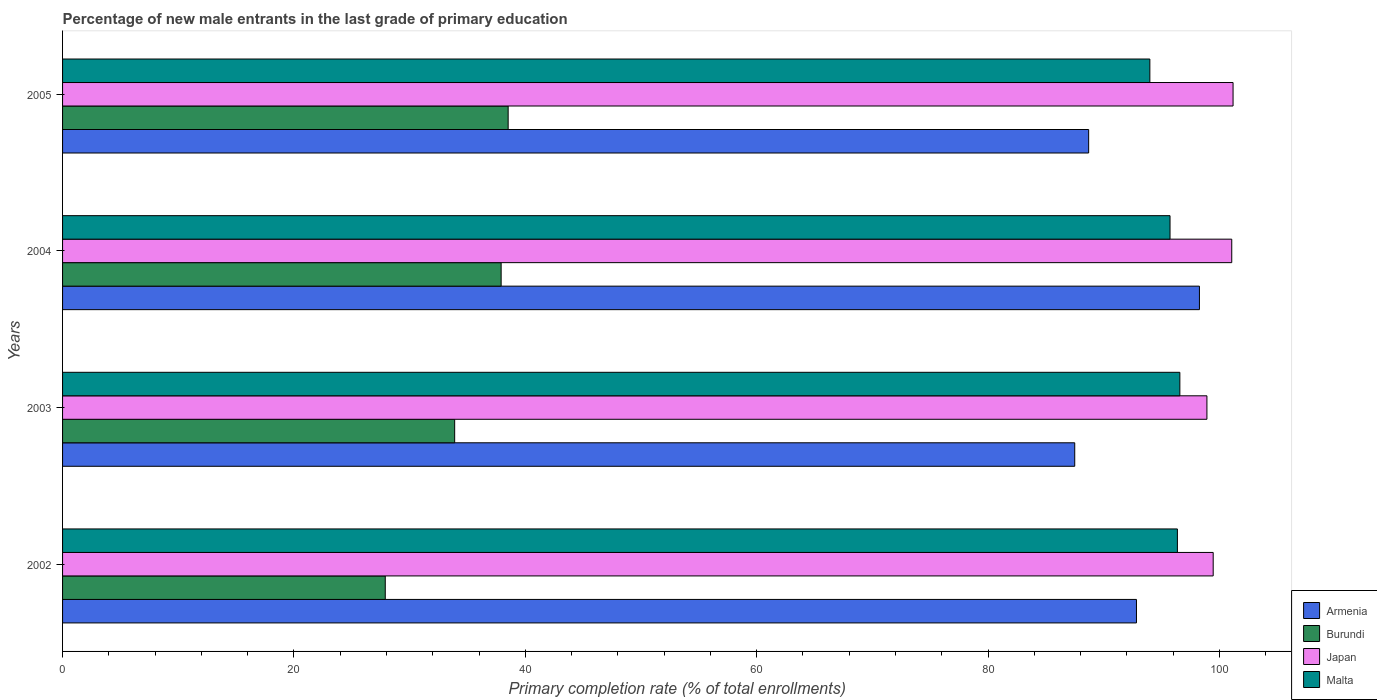How many different coloured bars are there?
Keep it short and to the point. 4. How many bars are there on the 1st tick from the top?
Keep it short and to the point. 4. What is the label of the 3rd group of bars from the top?
Ensure brevity in your answer.  2003. In how many cases, is the number of bars for a given year not equal to the number of legend labels?
Make the answer very short. 0. What is the percentage of new male entrants in Armenia in 2004?
Give a very brief answer. 98.27. Across all years, what is the maximum percentage of new male entrants in Armenia?
Offer a terse response. 98.27. Across all years, what is the minimum percentage of new male entrants in Malta?
Your answer should be compact. 93.99. In which year was the percentage of new male entrants in Burundi minimum?
Your response must be concise. 2002. What is the total percentage of new male entrants in Japan in the graph?
Your answer should be very brief. 400.63. What is the difference between the percentage of new male entrants in Japan in 2002 and that in 2003?
Ensure brevity in your answer.  0.54. What is the difference between the percentage of new male entrants in Armenia in 2005 and the percentage of new male entrants in Burundi in 2003?
Ensure brevity in your answer.  54.8. What is the average percentage of new male entrants in Japan per year?
Your answer should be compact. 100.16. In the year 2005, what is the difference between the percentage of new male entrants in Armenia and percentage of new male entrants in Burundi?
Provide a short and direct response. 50.18. In how many years, is the percentage of new male entrants in Burundi greater than 40 %?
Your answer should be compact. 0. What is the ratio of the percentage of new male entrants in Malta in 2003 to that in 2005?
Make the answer very short. 1.03. Is the percentage of new male entrants in Malta in 2003 less than that in 2004?
Offer a terse response. No. Is the difference between the percentage of new male entrants in Armenia in 2004 and 2005 greater than the difference between the percentage of new male entrants in Burundi in 2004 and 2005?
Provide a short and direct response. Yes. What is the difference between the highest and the second highest percentage of new male entrants in Armenia?
Give a very brief answer. 5.44. What is the difference between the highest and the lowest percentage of new male entrants in Burundi?
Your response must be concise. 10.62. In how many years, is the percentage of new male entrants in Armenia greater than the average percentage of new male entrants in Armenia taken over all years?
Provide a short and direct response. 2. Is the sum of the percentage of new male entrants in Malta in 2002 and 2004 greater than the maximum percentage of new male entrants in Japan across all years?
Offer a very short reply. Yes. Is it the case that in every year, the sum of the percentage of new male entrants in Burundi and percentage of new male entrants in Armenia is greater than the sum of percentage of new male entrants in Malta and percentage of new male entrants in Japan?
Offer a very short reply. Yes. What does the 1st bar from the top in 2005 represents?
Provide a succinct answer. Malta. Does the graph contain any zero values?
Offer a very short reply. No. Does the graph contain grids?
Provide a succinct answer. No. What is the title of the graph?
Give a very brief answer. Percentage of new male entrants in the last grade of primary education. What is the label or title of the X-axis?
Keep it short and to the point. Primary completion rate (% of total enrollments). What is the label or title of the Y-axis?
Make the answer very short. Years. What is the Primary completion rate (% of total enrollments) of Armenia in 2002?
Give a very brief answer. 92.83. What is the Primary completion rate (% of total enrollments) of Burundi in 2002?
Give a very brief answer. 27.89. What is the Primary completion rate (% of total enrollments) in Japan in 2002?
Your answer should be compact. 99.46. What is the Primary completion rate (% of total enrollments) in Malta in 2002?
Provide a succinct answer. 96.37. What is the Primary completion rate (% of total enrollments) in Armenia in 2003?
Offer a terse response. 87.49. What is the Primary completion rate (% of total enrollments) in Burundi in 2003?
Provide a short and direct response. 33.89. What is the Primary completion rate (% of total enrollments) in Japan in 2003?
Provide a succinct answer. 98.92. What is the Primary completion rate (% of total enrollments) of Malta in 2003?
Offer a terse response. 96.58. What is the Primary completion rate (% of total enrollments) of Armenia in 2004?
Your answer should be very brief. 98.27. What is the Primary completion rate (% of total enrollments) of Burundi in 2004?
Your answer should be compact. 37.91. What is the Primary completion rate (% of total enrollments) of Japan in 2004?
Provide a short and direct response. 101.07. What is the Primary completion rate (% of total enrollments) in Malta in 2004?
Give a very brief answer. 95.73. What is the Primary completion rate (% of total enrollments) of Armenia in 2005?
Give a very brief answer. 88.7. What is the Primary completion rate (% of total enrollments) of Burundi in 2005?
Your response must be concise. 38.52. What is the Primary completion rate (% of total enrollments) of Japan in 2005?
Offer a very short reply. 101.18. What is the Primary completion rate (% of total enrollments) of Malta in 2005?
Your answer should be very brief. 93.99. Across all years, what is the maximum Primary completion rate (% of total enrollments) of Armenia?
Provide a succinct answer. 98.27. Across all years, what is the maximum Primary completion rate (% of total enrollments) in Burundi?
Your answer should be very brief. 38.52. Across all years, what is the maximum Primary completion rate (% of total enrollments) of Japan?
Provide a short and direct response. 101.18. Across all years, what is the maximum Primary completion rate (% of total enrollments) of Malta?
Ensure brevity in your answer.  96.58. Across all years, what is the minimum Primary completion rate (% of total enrollments) in Armenia?
Give a very brief answer. 87.49. Across all years, what is the minimum Primary completion rate (% of total enrollments) of Burundi?
Your answer should be very brief. 27.89. Across all years, what is the minimum Primary completion rate (% of total enrollments) in Japan?
Make the answer very short. 98.92. Across all years, what is the minimum Primary completion rate (% of total enrollments) in Malta?
Provide a short and direct response. 93.99. What is the total Primary completion rate (% of total enrollments) in Armenia in the graph?
Give a very brief answer. 367.29. What is the total Primary completion rate (% of total enrollments) in Burundi in the graph?
Offer a terse response. 138.22. What is the total Primary completion rate (% of total enrollments) in Japan in the graph?
Offer a very short reply. 400.63. What is the total Primary completion rate (% of total enrollments) of Malta in the graph?
Offer a very short reply. 382.67. What is the difference between the Primary completion rate (% of total enrollments) in Armenia in 2002 and that in 2003?
Give a very brief answer. 5.34. What is the difference between the Primary completion rate (% of total enrollments) in Burundi in 2002 and that in 2003?
Keep it short and to the point. -6. What is the difference between the Primary completion rate (% of total enrollments) in Japan in 2002 and that in 2003?
Ensure brevity in your answer.  0.54. What is the difference between the Primary completion rate (% of total enrollments) of Malta in 2002 and that in 2003?
Keep it short and to the point. -0.21. What is the difference between the Primary completion rate (% of total enrollments) in Armenia in 2002 and that in 2004?
Provide a succinct answer. -5.44. What is the difference between the Primary completion rate (% of total enrollments) in Burundi in 2002 and that in 2004?
Give a very brief answer. -10.02. What is the difference between the Primary completion rate (% of total enrollments) of Japan in 2002 and that in 2004?
Offer a very short reply. -1.6. What is the difference between the Primary completion rate (% of total enrollments) in Malta in 2002 and that in 2004?
Offer a very short reply. 0.64. What is the difference between the Primary completion rate (% of total enrollments) in Armenia in 2002 and that in 2005?
Your answer should be compact. 4.13. What is the difference between the Primary completion rate (% of total enrollments) in Burundi in 2002 and that in 2005?
Ensure brevity in your answer.  -10.62. What is the difference between the Primary completion rate (% of total enrollments) in Japan in 2002 and that in 2005?
Your answer should be compact. -1.72. What is the difference between the Primary completion rate (% of total enrollments) in Malta in 2002 and that in 2005?
Your answer should be very brief. 2.38. What is the difference between the Primary completion rate (% of total enrollments) in Armenia in 2003 and that in 2004?
Offer a terse response. -10.78. What is the difference between the Primary completion rate (% of total enrollments) of Burundi in 2003 and that in 2004?
Provide a succinct answer. -4.02. What is the difference between the Primary completion rate (% of total enrollments) of Japan in 2003 and that in 2004?
Your response must be concise. -2.15. What is the difference between the Primary completion rate (% of total enrollments) of Armenia in 2003 and that in 2005?
Make the answer very short. -1.2. What is the difference between the Primary completion rate (% of total enrollments) of Burundi in 2003 and that in 2005?
Keep it short and to the point. -4.62. What is the difference between the Primary completion rate (% of total enrollments) in Japan in 2003 and that in 2005?
Ensure brevity in your answer.  -2.26. What is the difference between the Primary completion rate (% of total enrollments) in Malta in 2003 and that in 2005?
Provide a succinct answer. 2.59. What is the difference between the Primary completion rate (% of total enrollments) of Armenia in 2004 and that in 2005?
Give a very brief answer. 9.58. What is the difference between the Primary completion rate (% of total enrollments) of Burundi in 2004 and that in 2005?
Your response must be concise. -0.61. What is the difference between the Primary completion rate (% of total enrollments) in Japan in 2004 and that in 2005?
Ensure brevity in your answer.  -0.11. What is the difference between the Primary completion rate (% of total enrollments) of Malta in 2004 and that in 2005?
Offer a terse response. 1.74. What is the difference between the Primary completion rate (% of total enrollments) of Armenia in 2002 and the Primary completion rate (% of total enrollments) of Burundi in 2003?
Your response must be concise. 58.94. What is the difference between the Primary completion rate (% of total enrollments) in Armenia in 2002 and the Primary completion rate (% of total enrollments) in Japan in 2003?
Make the answer very short. -6.09. What is the difference between the Primary completion rate (% of total enrollments) of Armenia in 2002 and the Primary completion rate (% of total enrollments) of Malta in 2003?
Your answer should be compact. -3.75. What is the difference between the Primary completion rate (% of total enrollments) of Burundi in 2002 and the Primary completion rate (% of total enrollments) of Japan in 2003?
Your response must be concise. -71.03. What is the difference between the Primary completion rate (% of total enrollments) of Burundi in 2002 and the Primary completion rate (% of total enrollments) of Malta in 2003?
Your answer should be compact. -68.69. What is the difference between the Primary completion rate (% of total enrollments) of Japan in 2002 and the Primary completion rate (% of total enrollments) of Malta in 2003?
Your response must be concise. 2.88. What is the difference between the Primary completion rate (% of total enrollments) in Armenia in 2002 and the Primary completion rate (% of total enrollments) in Burundi in 2004?
Offer a terse response. 54.92. What is the difference between the Primary completion rate (% of total enrollments) of Armenia in 2002 and the Primary completion rate (% of total enrollments) of Japan in 2004?
Your answer should be compact. -8.24. What is the difference between the Primary completion rate (% of total enrollments) in Armenia in 2002 and the Primary completion rate (% of total enrollments) in Malta in 2004?
Your answer should be compact. -2.9. What is the difference between the Primary completion rate (% of total enrollments) of Burundi in 2002 and the Primary completion rate (% of total enrollments) of Japan in 2004?
Ensure brevity in your answer.  -73.17. What is the difference between the Primary completion rate (% of total enrollments) in Burundi in 2002 and the Primary completion rate (% of total enrollments) in Malta in 2004?
Give a very brief answer. -67.84. What is the difference between the Primary completion rate (% of total enrollments) in Japan in 2002 and the Primary completion rate (% of total enrollments) in Malta in 2004?
Your response must be concise. 3.73. What is the difference between the Primary completion rate (% of total enrollments) of Armenia in 2002 and the Primary completion rate (% of total enrollments) of Burundi in 2005?
Keep it short and to the point. 54.31. What is the difference between the Primary completion rate (% of total enrollments) of Armenia in 2002 and the Primary completion rate (% of total enrollments) of Japan in 2005?
Provide a short and direct response. -8.35. What is the difference between the Primary completion rate (% of total enrollments) in Armenia in 2002 and the Primary completion rate (% of total enrollments) in Malta in 2005?
Your answer should be very brief. -1.16. What is the difference between the Primary completion rate (% of total enrollments) of Burundi in 2002 and the Primary completion rate (% of total enrollments) of Japan in 2005?
Offer a very short reply. -73.29. What is the difference between the Primary completion rate (% of total enrollments) of Burundi in 2002 and the Primary completion rate (% of total enrollments) of Malta in 2005?
Your answer should be very brief. -66.09. What is the difference between the Primary completion rate (% of total enrollments) of Japan in 2002 and the Primary completion rate (% of total enrollments) of Malta in 2005?
Ensure brevity in your answer.  5.47. What is the difference between the Primary completion rate (% of total enrollments) in Armenia in 2003 and the Primary completion rate (% of total enrollments) in Burundi in 2004?
Ensure brevity in your answer.  49.58. What is the difference between the Primary completion rate (% of total enrollments) of Armenia in 2003 and the Primary completion rate (% of total enrollments) of Japan in 2004?
Offer a very short reply. -13.57. What is the difference between the Primary completion rate (% of total enrollments) in Armenia in 2003 and the Primary completion rate (% of total enrollments) in Malta in 2004?
Offer a very short reply. -8.24. What is the difference between the Primary completion rate (% of total enrollments) of Burundi in 2003 and the Primary completion rate (% of total enrollments) of Japan in 2004?
Provide a short and direct response. -67.17. What is the difference between the Primary completion rate (% of total enrollments) of Burundi in 2003 and the Primary completion rate (% of total enrollments) of Malta in 2004?
Your answer should be compact. -61.84. What is the difference between the Primary completion rate (% of total enrollments) in Japan in 2003 and the Primary completion rate (% of total enrollments) in Malta in 2004?
Provide a short and direct response. 3.19. What is the difference between the Primary completion rate (% of total enrollments) in Armenia in 2003 and the Primary completion rate (% of total enrollments) in Burundi in 2005?
Offer a very short reply. 48.98. What is the difference between the Primary completion rate (% of total enrollments) of Armenia in 2003 and the Primary completion rate (% of total enrollments) of Japan in 2005?
Your response must be concise. -13.69. What is the difference between the Primary completion rate (% of total enrollments) in Armenia in 2003 and the Primary completion rate (% of total enrollments) in Malta in 2005?
Ensure brevity in your answer.  -6.49. What is the difference between the Primary completion rate (% of total enrollments) in Burundi in 2003 and the Primary completion rate (% of total enrollments) in Japan in 2005?
Give a very brief answer. -67.29. What is the difference between the Primary completion rate (% of total enrollments) in Burundi in 2003 and the Primary completion rate (% of total enrollments) in Malta in 2005?
Offer a very short reply. -60.09. What is the difference between the Primary completion rate (% of total enrollments) of Japan in 2003 and the Primary completion rate (% of total enrollments) of Malta in 2005?
Provide a succinct answer. 4.93. What is the difference between the Primary completion rate (% of total enrollments) in Armenia in 2004 and the Primary completion rate (% of total enrollments) in Burundi in 2005?
Offer a very short reply. 59.75. What is the difference between the Primary completion rate (% of total enrollments) of Armenia in 2004 and the Primary completion rate (% of total enrollments) of Japan in 2005?
Provide a succinct answer. -2.91. What is the difference between the Primary completion rate (% of total enrollments) in Armenia in 2004 and the Primary completion rate (% of total enrollments) in Malta in 2005?
Your answer should be very brief. 4.29. What is the difference between the Primary completion rate (% of total enrollments) in Burundi in 2004 and the Primary completion rate (% of total enrollments) in Japan in 2005?
Keep it short and to the point. -63.27. What is the difference between the Primary completion rate (% of total enrollments) of Burundi in 2004 and the Primary completion rate (% of total enrollments) of Malta in 2005?
Provide a succinct answer. -56.08. What is the difference between the Primary completion rate (% of total enrollments) in Japan in 2004 and the Primary completion rate (% of total enrollments) in Malta in 2005?
Your answer should be very brief. 7.08. What is the average Primary completion rate (% of total enrollments) in Armenia per year?
Your answer should be compact. 91.82. What is the average Primary completion rate (% of total enrollments) in Burundi per year?
Your answer should be compact. 34.55. What is the average Primary completion rate (% of total enrollments) in Japan per year?
Your response must be concise. 100.16. What is the average Primary completion rate (% of total enrollments) of Malta per year?
Provide a short and direct response. 95.67. In the year 2002, what is the difference between the Primary completion rate (% of total enrollments) in Armenia and Primary completion rate (% of total enrollments) in Burundi?
Your answer should be compact. 64.94. In the year 2002, what is the difference between the Primary completion rate (% of total enrollments) of Armenia and Primary completion rate (% of total enrollments) of Japan?
Provide a succinct answer. -6.63. In the year 2002, what is the difference between the Primary completion rate (% of total enrollments) of Armenia and Primary completion rate (% of total enrollments) of Malta?
Your answer should be very brief. -3.54. In the year 2002, what is the difference between the Primary completion rate (% of total enrollments) in Burundi and Primary completion rate (% of total enrollments) in Japan?
Your answer should be very brief. -71.57. In the year 2002, what is the difference between the Primary completion rate (% of total enrollments) in Burundi and Primary completion rate (% of total enrollments) in Malta?
Your answer should be compact. -68.47. In the year 2002, what is the difference between the Primary completion rate (% of total enrollments) of Japan and Primary completion rate (% of total enrollments) of Malta?
Ensure brevity in your answer.  3.09. In the year 2003, what is the difference between the Primary completion rate (% of total enrollments) in Armenia and Primary completion rate (% of total enrollments) in Burundi?
Offer a very short reply. 53.6. In the year 2003, what is the difference between the Primary completion rate (% of total enrollments) in Armenia and Primary completion rate (% of total enrollments) in Japan?
Keep it short and to the point. -11.43. In the year 2003, what is the difference between the Primary completion rate (% of total enrollments) in Armenia and Primary completion rate (% of total enrollments) in Malta?
Provide a short and direct response. -9.09. In the year 2003, what is the difference between the Primary completion rate (% of total enrollments) of Burundi and Primary completion rate (% of total enrollments) of Japan?
Give a very brief answer. -65.02. In the year 2003, what is the difference between the Primary completion rate (% of total enrollments) of Burundi and Primary completion rate (% of total enrollments) of Malta?
Ensure brevity in your answer.  -62.69. In the year 2003, what is the difference between the Primary completion rate (% of total enrollments) of Japan and Primary completion rate (% of total enrollments) of Malta?
Make the answer very short. 2.34. In the year 2004, what is the difference between the Primary completion rate (% of total enrollments) of Armenia and Primary completion rate (% of total enrollments) of Burundi?
Make the answer very short. 60.36. In the year 2004, what is the difference between the Primary completion rate (% of total enrollments) in Armenia and Primary completion rate (% of total enrollments) in Japan?
Offer a terse response. -2.79. In the year 2004, what is the difference between the Primary completion rate (% of total enrollments) in Armenia and Primary completion rate (% of total enrollments) in Malta?
Offer a terse response. 2.54. In the year 2004, what is the difference between the Primary completion rate (% of total enrollments) in Burundi and Primary completion rate (% of total enrollments) in Japan?
Offer a terse response. -63.16. In the year 2004, what is the difference between the Primary completion rate (% of total enrollments) in Burundi and Primary completion rate (% of total enrollments) in Malta?
Provide a succinct answer. -57.82. In the year 2004, what is the difference between the Primary completion rate (% of total enrollments) of Japan and Primary completion rate (% of total enrollments) of Malta?
Provide a short and direct response. 5.34. In the year 2005, what is the difference between the Primary completion rate (% of total enrollments) of Armenia and Primary completion rate (% of total enrollments) of Burundi?
Provide a succinct answer. 50.18. In the year 2005, what is the difference between the Primary completion rate (% of total enrollments) of Armenia and Primary completion rate (% of total enrollments) of Japan?
Make the answer very short. -12.48. In the year 2005, what is the difference between the Primary completion rate (% of total enrollments) in Armenia and Primary completion rate (% of total enrollments) in Malta?
Offer a terse response. -5.29. In the year 2005, what is the difference between the Primary completion rate (% of total enrollments) of Burundi and Primary completion rate (% of total enrollments) of Japan?
Your answer should be very brief. -62.66. In the year 2005, what is the difference between the Primary completion rate (% of total enrollments) of Burundi and Primary completion rate (% of total enrollments) of Malta?
Keep it short and to the point. -55.47. In the year 2005, what is the difference between the Primary completion rate (% of total enrollments) of Japan and Primary completion rate (% of total enrollments) of Malta?
Offer a terse response. 7.19. What is the ratio of the Primary completion rate (% of total enrollments) of Armenia in 2002 to that in 2003?
Your answer should be very brief. 1.06. What is the ratio of the Primary completion rate (% of total enrollments) in Burundi in 2002 to that in 2003?
Your answer should be very brief. 0.82. What is the ratio of the Primary completion rate (% of total enrollments) of Japan in 2002 to that in 2003?
Make the answer very short. 1.01. What is the ratio of the Primary completion rate (% of total enrollments) in Malta in 2002 to that in 2003?
Your answer should be very brief. 1. What is the ratio of the Primary completion rate (% of total enrollments) of Armenia in 2002 to that in 2004?
Ensure brevity in your answer.  0.94. What is the ratio of the Primary completion rate (% of total enrollments) in Burundi in 2002 to that in 2004?
Provide a succinct answer. 0.74. What is the ratio of the Primary completion rate (% of total enrollments) of Japan in 2002 to that in 2004?
Ensure brevity in your answer.  0.98. What is the ratio of the Primary completion rate (% of total enrollments) in Malta in 2002 to that in 2004?
Your answer should be very brief. 1.01. What is the ratio of the Primary completion rate (% of total enrollments) of Armenia in 2002 to that in 2005?
Provide a succinct answer. 1.05. What is the ratio of the Primary completion rate (% of total enrollments) of Burundi in 2002 to that in 2005?
Give a very brief answer. 0.72. What is the ratio of the Primary completion rate (% of total enrollments) of Japan in 2002 to that in 2005?
Ensure brevity in your answer.  0.98. What is the ratio of the Primary completion rate (% of total enrollments) in Malta in 2002 to that in 2005?
Provide a short and direct response. 1.03. What is the ratio of the Primary completion rate (% of total enrollments) of Armenia in 2003 to that in 2004?
Give a very brief answer. 0.89. What is the ratio of the Primary completion rate (% of total enrollments) of Burundi in 2003 to that in 2004?
Provide a short and direct response. 0.89. What is the ratio of the Primary completion rate (% of total enrollments) in Japan in 2003 to that in 2004?
Ensure brevity in your answer.  0.98. What is the ratio of the Primary completion rate (% of total enrollments) of Malta in 2003 to that in 2004?
Keep it short and to the point. 1.01. What is the ratio of the Primary completion rate (% of total enrollments) in Armenia in 2003 to that in 2005?
Offer a terse response. 0.99. What is the ratio of the Primary completion rate (% of total enrollments) of Japan in 2003 to that in 2005?
Ensure brevity in your answer.  0.98. What is the ratio of the Primary completion rate (% of total enrollments) in Malta in 2003 to that in 2005?
Offer a terse response. 1.03. What is the ratio of the Primary completion rate (% of total enrollments) of Armenia in 2004 to that in 2005?
Your answer should be very brief. 1.11. What is the ratio of the Primary completion rate (% of total enrollments) in Burundi in 2004 to that in 2005?
Provide a short and direct response. 0.98. What is the ratio of the Primary completion rate (% of total enrollments) in Malta in 2004 to that in 2005?
Offer a terse response. 1.02. What is the difference between the highest and the second highest Primary completion rate (% of total enrollments) in Armenia?
Offer a very short reply. 5.44. What is the difference between the highest and the second highest Primary completion rate (% of total enrollments) of Burundi?
Offer a terse response. 0.61. What is the difference between the highest and the second highest Primary completion rate (% of total enrollments) of Japan?
Ensure brevity in your answer.  0.11. What is the difference between the highest and the second highest Primary completion rate (% of total enrollments) of Malta?
Offer a very short reply. 0.21. What is the difference between the highest and the lowest Primary completion rate (% of total enrollments) in Armenia?
Ensure brevity in your answer.  10.78. What is the difference between the highest and the lowest Primary completion rate (% of total enrollments) of Burundi?
Keep it short and to the point. 10.62. What is the difference between the highest and the lowest Primary completion rate (% of total enrollments) in Japan?
Keep it short and to the point. 2.26. What is the difference between the highest and the lowest Primary completion rate (% of total enrollments) in Malta?
Provide a succinct answer. 2.59. 